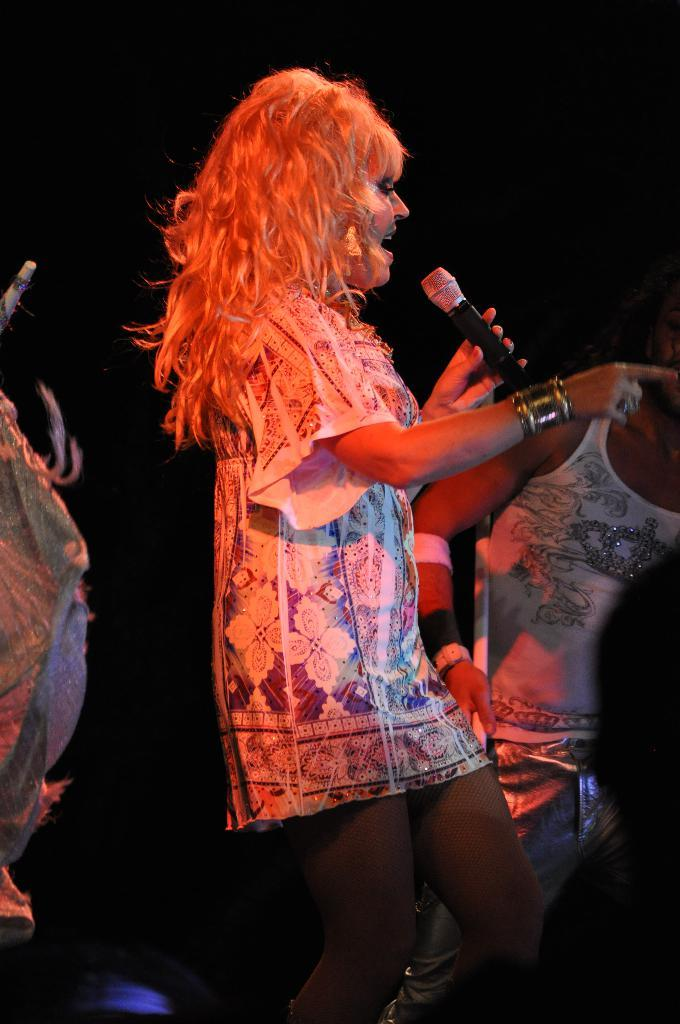What is the person in the image doing? The person in the image is singing. What object is the singer holding in her hand? The singer is holding a microphone in her hand. Can you describe the person visible behind the singer? There is another person visible behind the singer, but no specific details about this person are provided in the facts. What type of horse can be seen reacting to the singer's performance in the image? There is no horse present in the image, and therefore no reaction from a horse can be observed. 